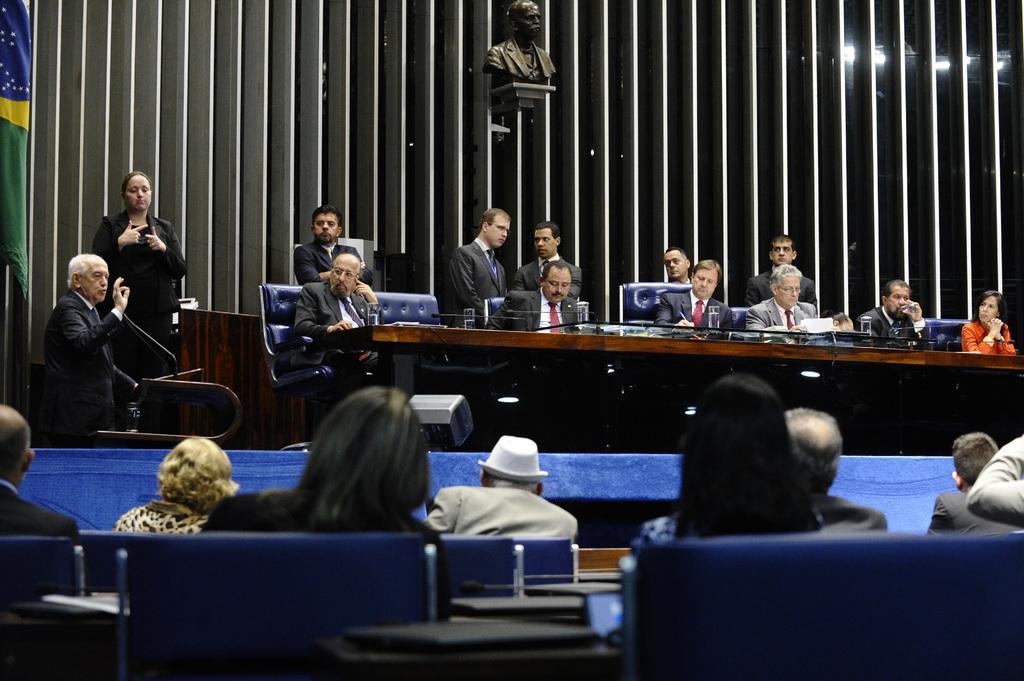How would you summarize this image in a sentence or two? there are so many men standing and sitting in a meeting room behind a table and there is a sculpture in the middle of the room. 